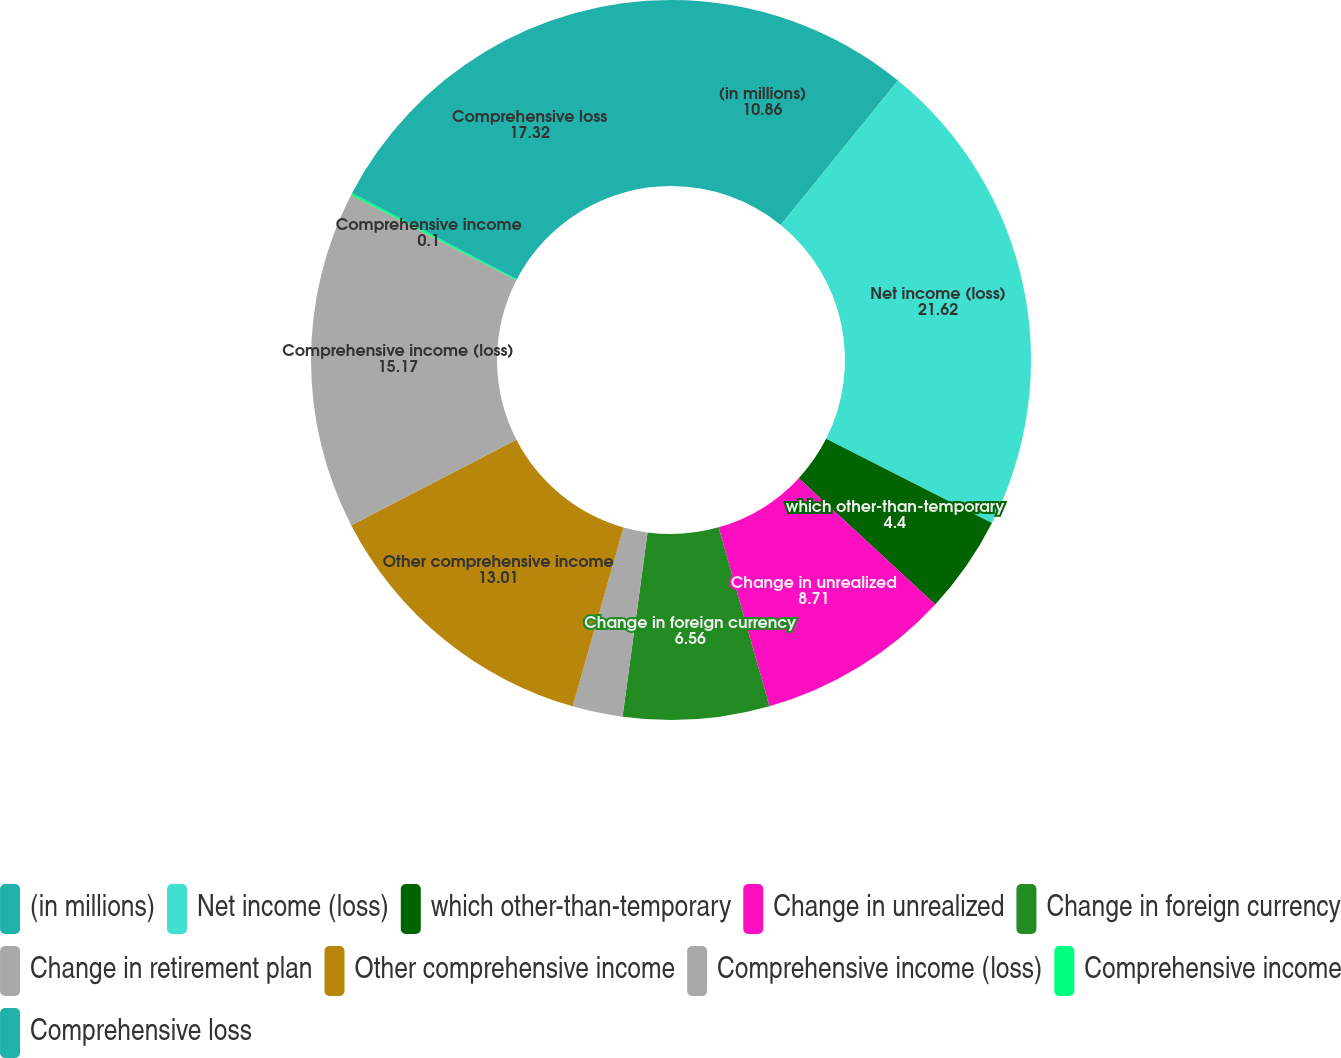<chart> <loc_0><loc_0><loc_500><loc_500><pie_chart><fcel>(in millions)<fcel>Net income (loss)<fcel>which other-than-temporary<fcel>Change in unrealized<fcel>Change in foreign currency<fcel>Change in retirement plan<fcel>Other comprehensive income<fcel>Comprehensive income (loss)<fcel>Comprehensive income<fcel>Comprehensive loss<nl><fcel>10.86%<fcel>21.62%<fcel>4.4%<fcel>8.71%<fcel>6.56%<fcel>2.25%<fcel>13.01%<fcel>15.17%<fcel>0.1%<fcel>17.32%<nl></chart> 